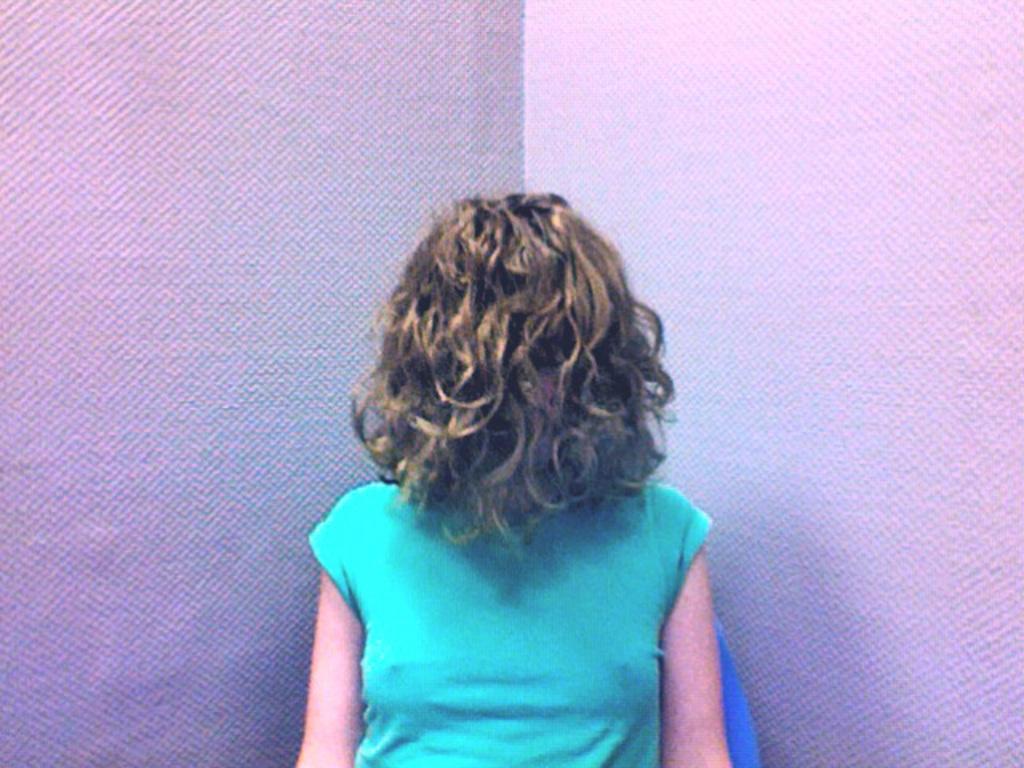Could you give a brief overview of what you see in this image? In this image I can see a person wearing a green color t-shirt and background is white 